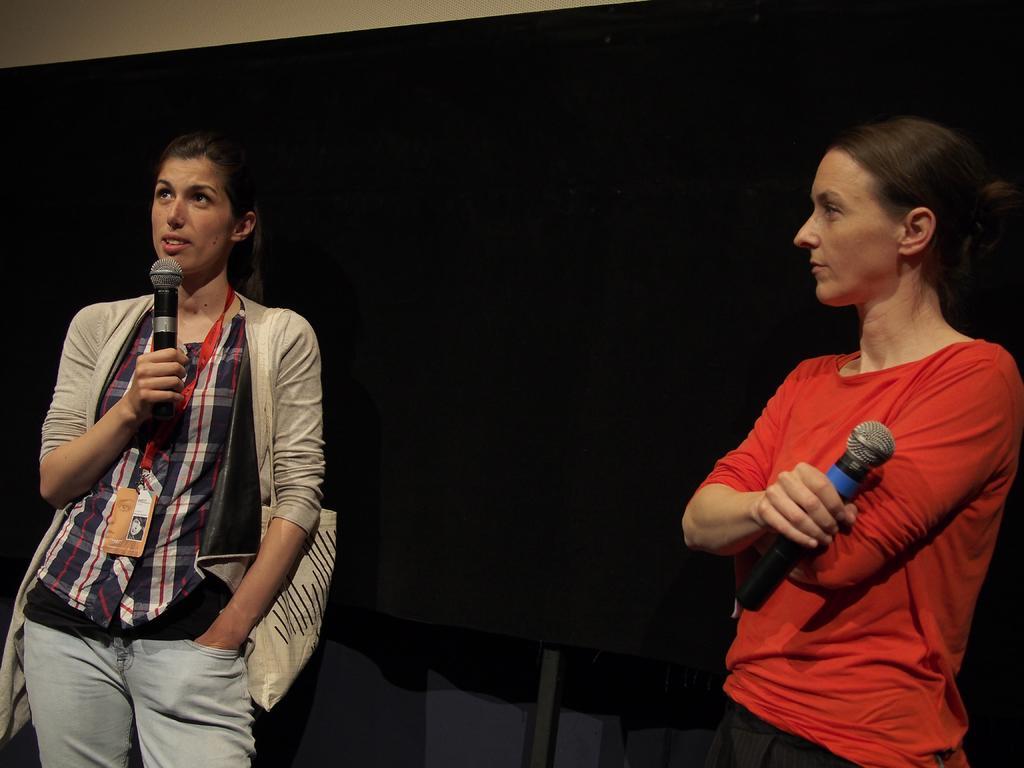Describe this image in one or two sentences. In this image there are 2 women standing and holding a microphone. 